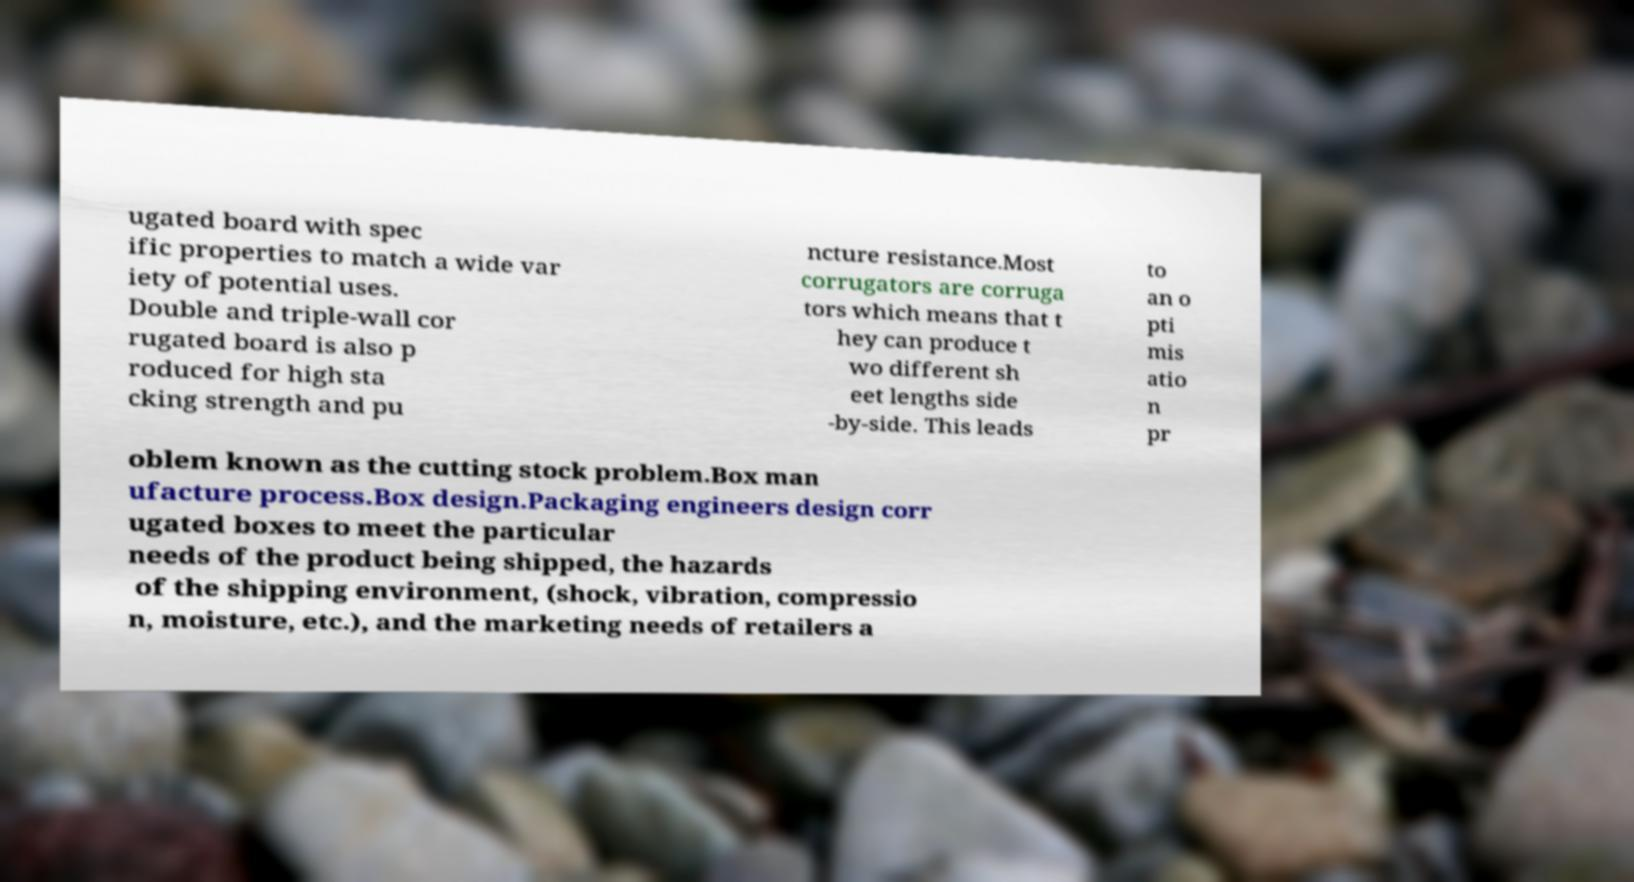Please read and relay the text visible in this image. What does it say? ugated board with spec ific properties to match a wide var iety of potential uses. Double and triple-wall cor rugated board is also p roduced for high sta cking strength and pu ncture resistance.Most corrugators are corruga tors which means that t hey can produce t wo different sh eet lengths side -by-side. This leads to an o pti mis atio n pr oblem known as the cutting stock problem.Box man ufacture process.Box design.Packaging engineers design corr ugated boxes to meet the particular needs of the product being shipped, the hazards of the shipping environment, (shock, vibration, compressio n, moisture, etc.), and the marketing needs of retailers a 